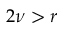Convert formula to latex. <formula><loc_0><loc_0><loc_500><loc_500>2 \nu > r</formula> 